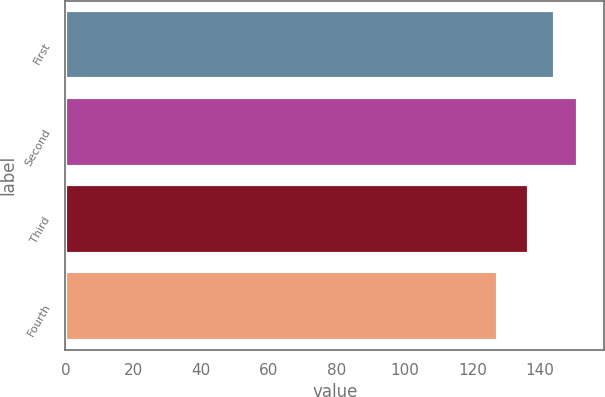Convert chart to OTSL. <chart><loc_0><loc_0><loc_500><loc_500><bar_chart><fcel>First<fcel>Second<fcel>Third<fcel>Fourth<nl><fcel>144.23<fcel>151.28<fcel>136.83<fcel>127.58<nl></chart> 